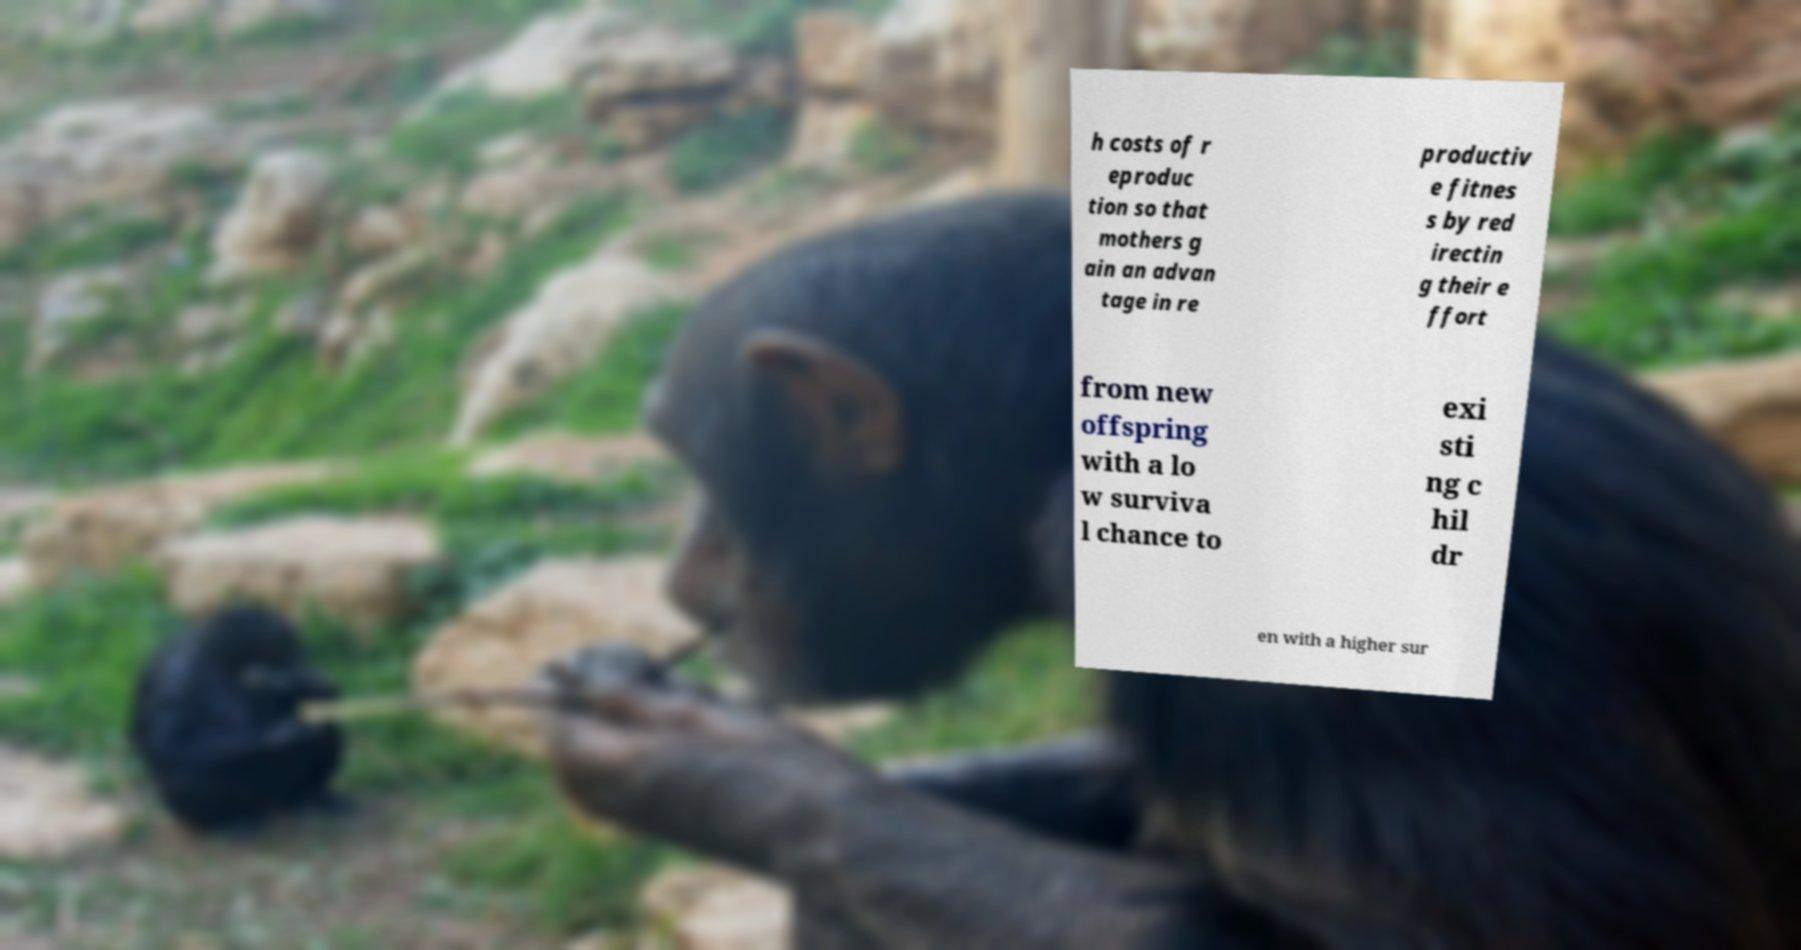Could you assist in decoding the text presented in this image and type it out clearly? h costs of r eproduc tion so that mothers g ain an advan tage in re productiv e fitnes s by red irectin g their e ffort from new offspring with a lo w surviva l chance to exi sti ng c hil dr en with a higher sur 